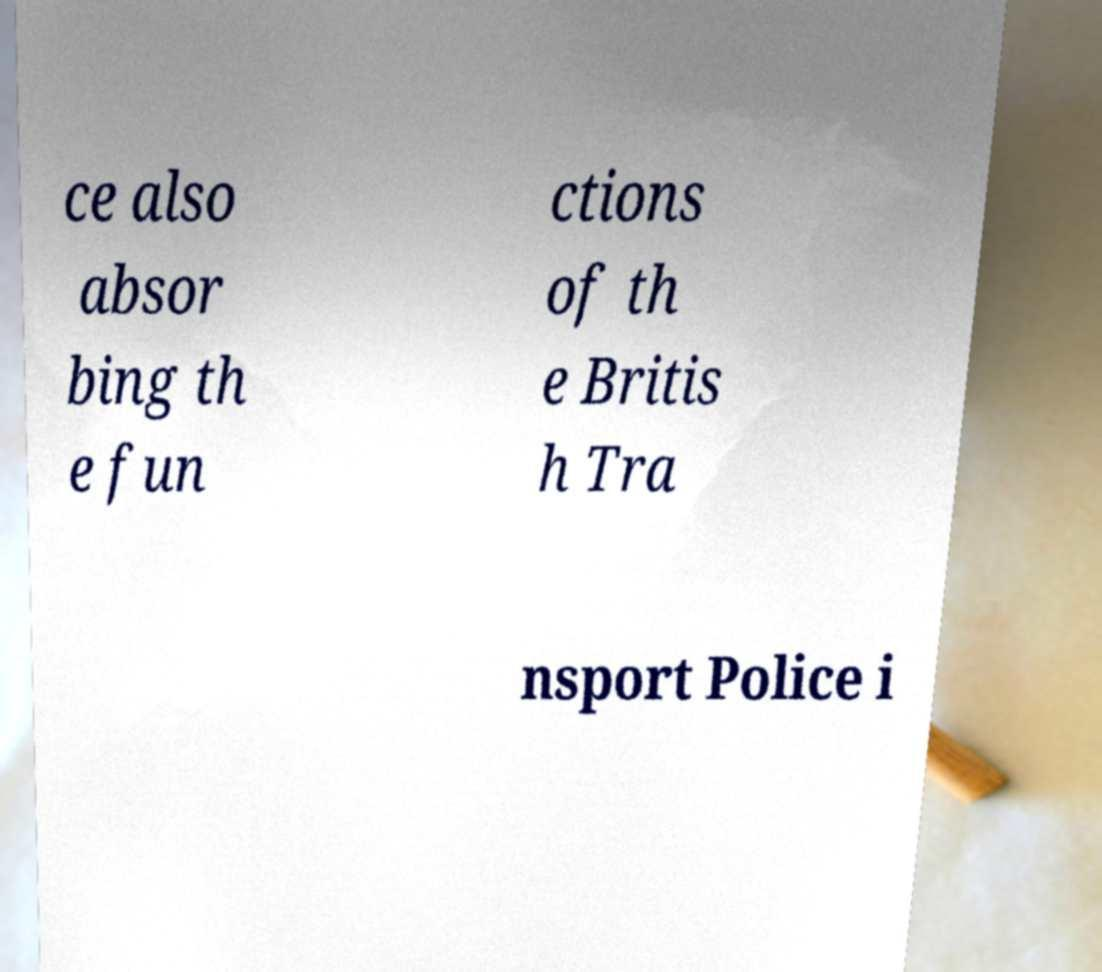I need the written content from this picture converted into text. Can you do that? ce also absor bing th e fun ctions of th e Britis h Tra nsport Police i 